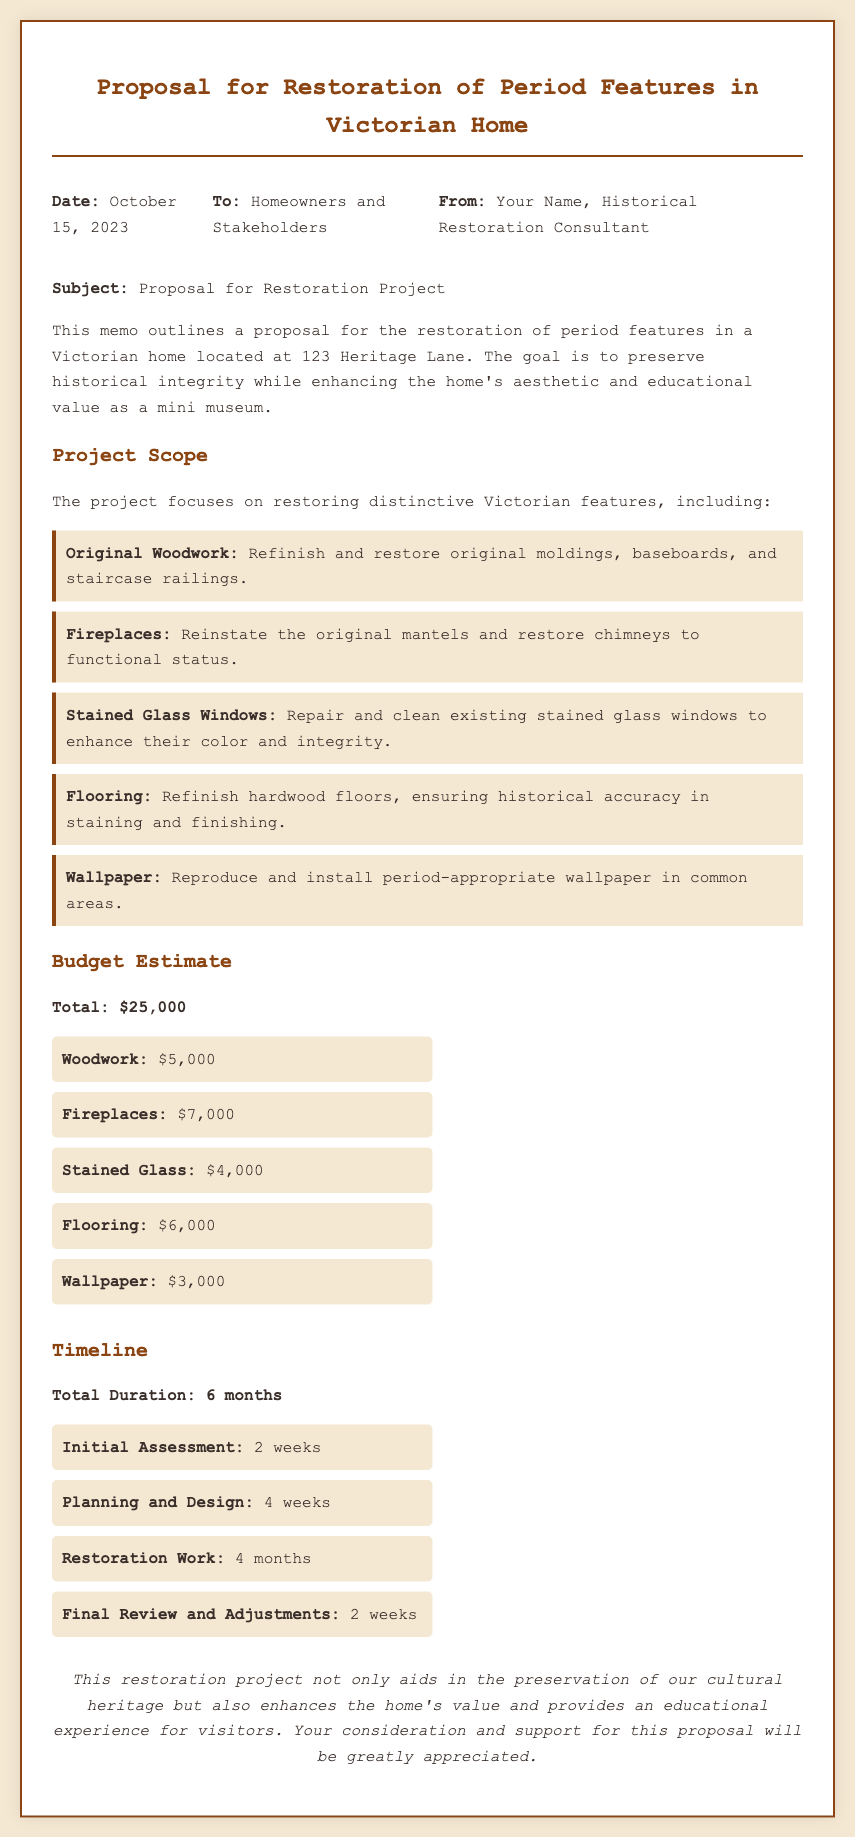what is the date of the proposal? The date of the proposal is stated at the top of the memo.
Answer: October 15, 2023 who is the memo addressed to? The memo includes the recipients in the header section.
Answer: Homeowners and Stakeholders what is the total budget for the restoration project? The total budget is listed under the Budget Estimate section of the memo.
Answer: $25,000 how long is the restoration work anticipated to take? The duration for the restoration work is specified in the Timeline section.
Answer: 4 months what feature involves restoring the original mantels? The feature related to mantels can be found in the Project Scope section.
Answer: Fireplaces how much is allocated for the stained glass windows? The budget for stained glass is detailed in the Budget Estimate section.
Answer: $4,000 what is the total duration of the project? The total duration is mentioned in the Timeline section of the memo.
Answer: 6 months what is the initial assessment duration? The duration for the initial assessment is outlined in the Timeline section.
Answer: 2 weeks what are the original woodwork tasks specified? The specific tasks for original woodwork are mentioned in the Project Scope section.
Answer: Refinish and restore original moldings, baseboards, and staircase railings 